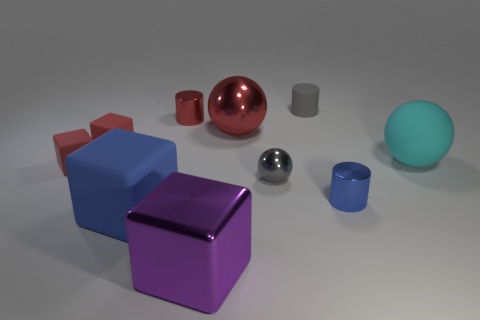Subtract 1 spheres. How many spheres are left? 2 Subtract all purple cubes. How many cubes are left? 3 Subtract all brown cubes. Subtract all cyan cylinders. How many cubes are left? 4 Subtract all spheres. How many objects are left? 7 Subtract all big red balls. Subtract all blue things. How many objects are left? 7 Add 6 big cubes. How many big cubes are left? 8 Add 9 tiny gray metallic balls. How many tiny gray metallic balls exist? 10 Subtract 0 yellow cylinders. How many objects are left? 10 